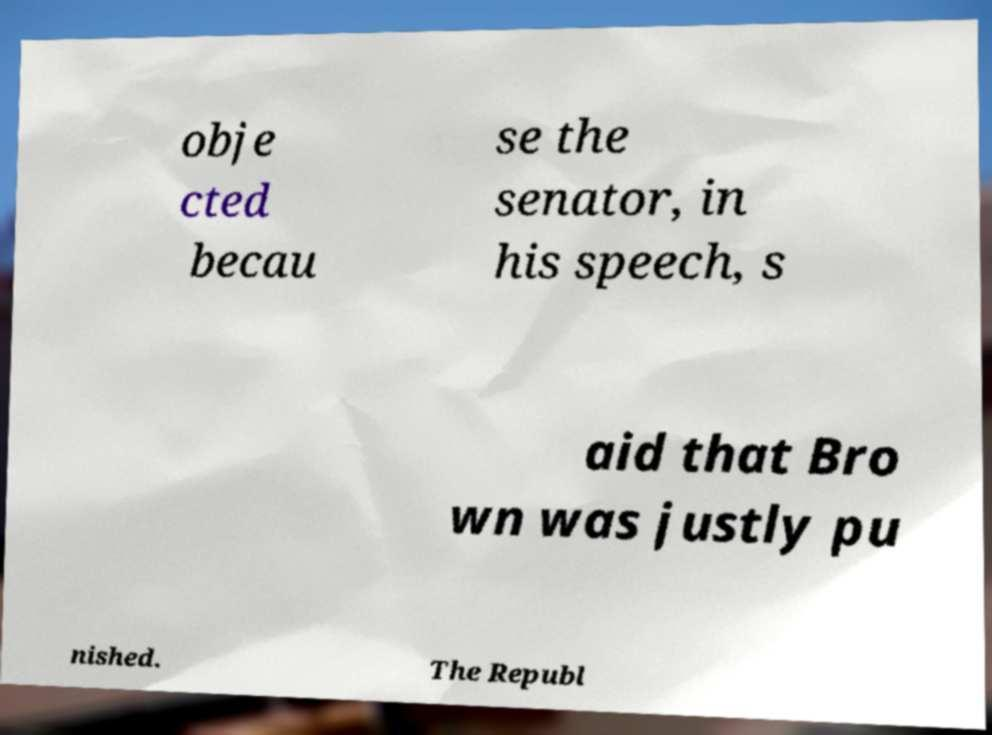Could you assist in decoding the text presented in this image and type it out clearly? obje cted becau se the senator, in his speech, s aid that Bro wn was justly pu nished. The Republ 